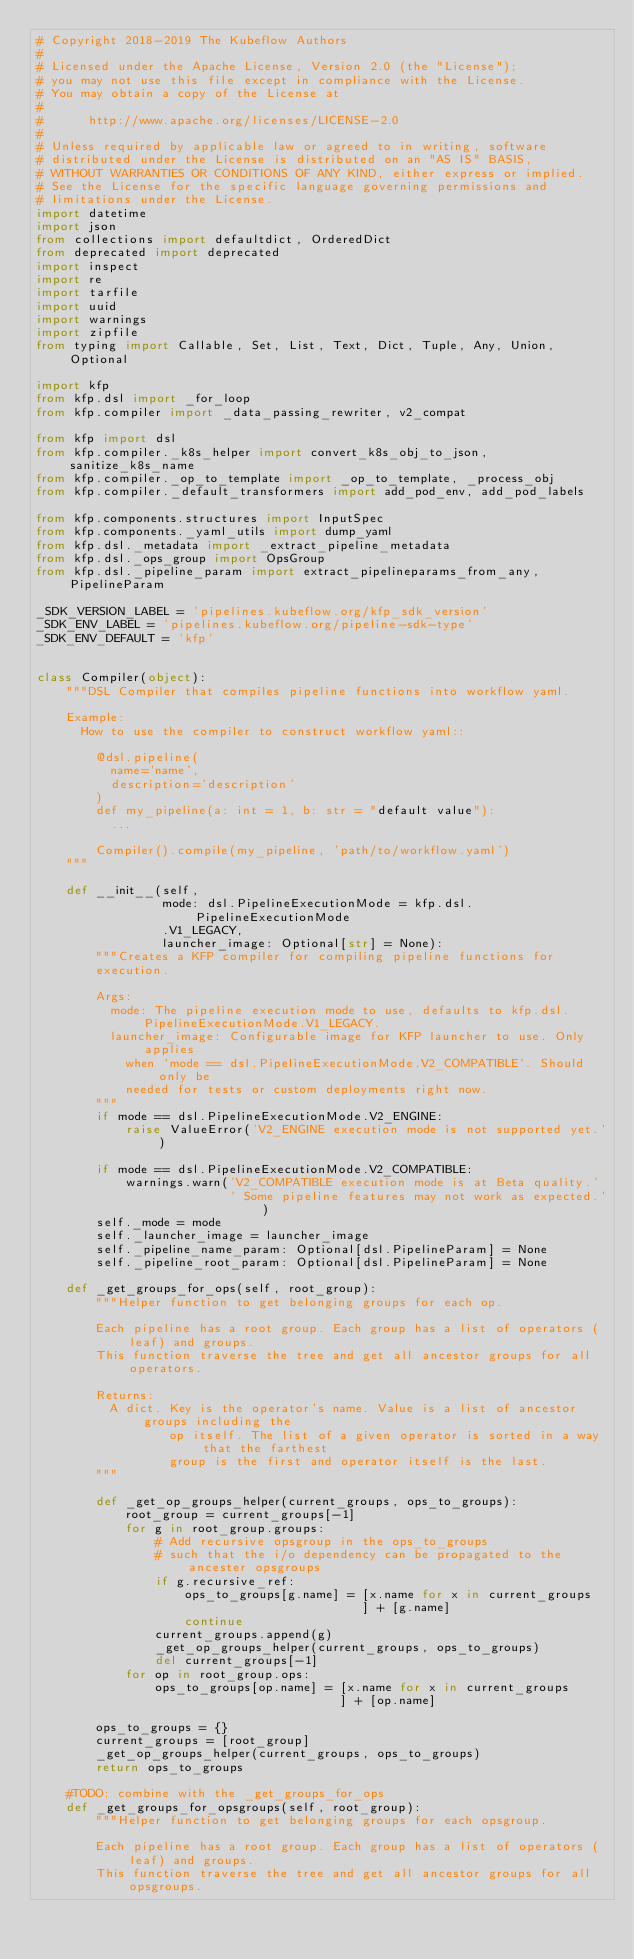<code> <loc_0><loc_0><loc_500><loc_500><_Python_># Copyright 2018-2019 The Kubeflow Authors
#
# Licensed under the Apache License, Version 2.0 (the "License");
# you may not use this file except in compliance with the License.
# You may obtain a copy of the License at
#
#      http://www.apache.org/licenses/LICENSE-2.0
#
# Unless required by applicable law or agreed to in writing, software
# distributed under the License is distributed on an "AS IS" BASIS,
# WITHOUT WARRANTIES OR CONDITIONS OF ANY KIND, either express or implied.
# See the License for the specific language governing permissions and
# limitations under the License.
import datetime
import json
from collections import defaultdict, OrderedDict
from deprecated import deprecated
import inspect
import re
import tarfile
import uuid
import warnings
import zipfile
from typing import Callable, Set, List, Text, Dict, Tuple, Any, Union, Optional

import kfp
from kfp.dsl import _for_loop
from kfp.compiler import _data_passing_rewriter, v2_compat

from kfp import dsl
from kfp.compiler._k8s_helper import convert_k8s_obj_to_json, sanitize_k8s_name
from kfp.compiler._op_to_template import _op_to_template, _process_obj
from kfp.compiler._default_transformers import add_pod_env, add_pod_labels

from kfp.components.structures import InputSpec
from kfp.components._yaml_utils import dump_yaml
from kfp.dsl._metadata import _extract_pipeline_metadata
from kfp.dsl._ops_group import OpsGroup
from kfp.dsl._pipeline_param import extract_pipelineparams_from_any, PipelineParam

_SDK_VERSION_LABEL = 'pipelines.kubeflow.org/kfp_sdk_version'
_SDK_ENV_LABEL = 'pipelines.kubeflow.org/pipeline-sdk-type'
_SDK_ENV_DEFAULT = 'kfp'


class Compiler(object):
    """DSL Compiler that compiles pipeline functions into workflow yaml.

    Example:
      How to use the compiler to construct workflow yaml::

        @dsl.pipeline(
          name='name',
          description='description'
        )
        def my_pipeline(a: int = 1, b: str = "default value"):
          ...

        Compiler().compile(my_pipeline, 'path/to/workflow.yaml')
    """

    def __init__(self,
                 mode: dsl.PipelineExecutionMode = kfp.dsl.PipelineExecutionMode
                 .V1_LEGACY,
                 launcher_image: Optional[str] = None):
        """Creates a KFP compiler for compiling pipeline functions for
        execution.

        Args:
          mode: The pipeline execution mode to use, defaults to kfp.dsl.PipelineExecutionMode.V1_LEGACY.
          launcher_image: Configurable image for KFP launcher to use. Only applies
            when `mode == dsl.PipelineExecutionMode.V2_COMPATIBLE`. Should only be
            needed for tests or custom deployments right now.
        """
        if mode == dsl.PipelineExecutionMode.V2_ENGINE:
            raise ValueError('V2_ENGINE execution mode is not supported yet.')

        if mode == dsl.PipelineExecutionMode.V2_COMPATIBLE:
            warnings.warn('V2_COMPATIBLE execution mode is at Beta quality.'
                          ' Some pipeline features may not work as expected.')
        self._mode = mode
        self._launcher_image = launcher_image
        self._pipeline_name_param: Optional[dsl.PipelineParam] = None
        self._pipeline_root_param: Optional[dsl.PipelineParam] = None

    def _get_groups_for_ops(self, root_group):
        """Helper function to get belonging groups for each op.

        Each pipeline has a root group. Each group has a list of operators (leaf) and groups.
        This function traverse the tree and get all ancestor groups for all operators.

        Returns:
          A dict. Key is the operator's name. Value is a list of ancestor groups including the
                  op itself. The list of a given operator is sorted in a way that the farthest
                  group is the first and operator itself is the last.
        """

        def _get_op_groups_helper(current_groups, ops_to_groups):
            root_group = current_groups[-1]
            for g in root_group.groups:
                # Add recursive opsgroup in the ops_to_groups
                # such that the i/o dependency can be propagated to the ancester opsgroups
                if g.recursive_ref:
                    ops_to_groups[g.name] = [x.name for x in current_groups
                                            ] + [g.name]
                    continue
                current_groups.append(g)
                _get_op_groups_helper(current_groups, ops_to_groups)
                del current_groups[-1]
            for op in root_group.ops:
                ops_to_groups[op.name] = [x.name for x in current_groups
                                         ] + [op.name]

        ops_to_groups = {}
        current_groups = [root_group]
        _get_op_groups_helper(current_groups, ops_to_groups)
        return ops_to_groups

    #TODO: combine with the _get_groups_for_ops
    def _get_groups_for_opsgroups(self, root_group):
        """Helper function to get belonging groups for each opsgroup.

        Each pipeline has a root group. Each group has a list of operators (leaf) and groups.
        This function traverse the tree and get all ancestor groups for all opsgroups.
</code> 